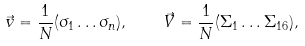Convert formula to latex. <formula><loc_0><loc_0><loc_500><loc_500>\vec { v } = \frac { 1 } { N } ( \sigma _ { 1 } \dots \sigma _ { n } ) , \quad \vec { V } = \frac { 1 } { N } ( \Sigma _ { 1 } \dots \Sigma _ { 1 6 } ) ,</formula> 